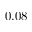<formula> <loc_0><loc_0><loc_500><loc_500>0 . 0 8</formula> 